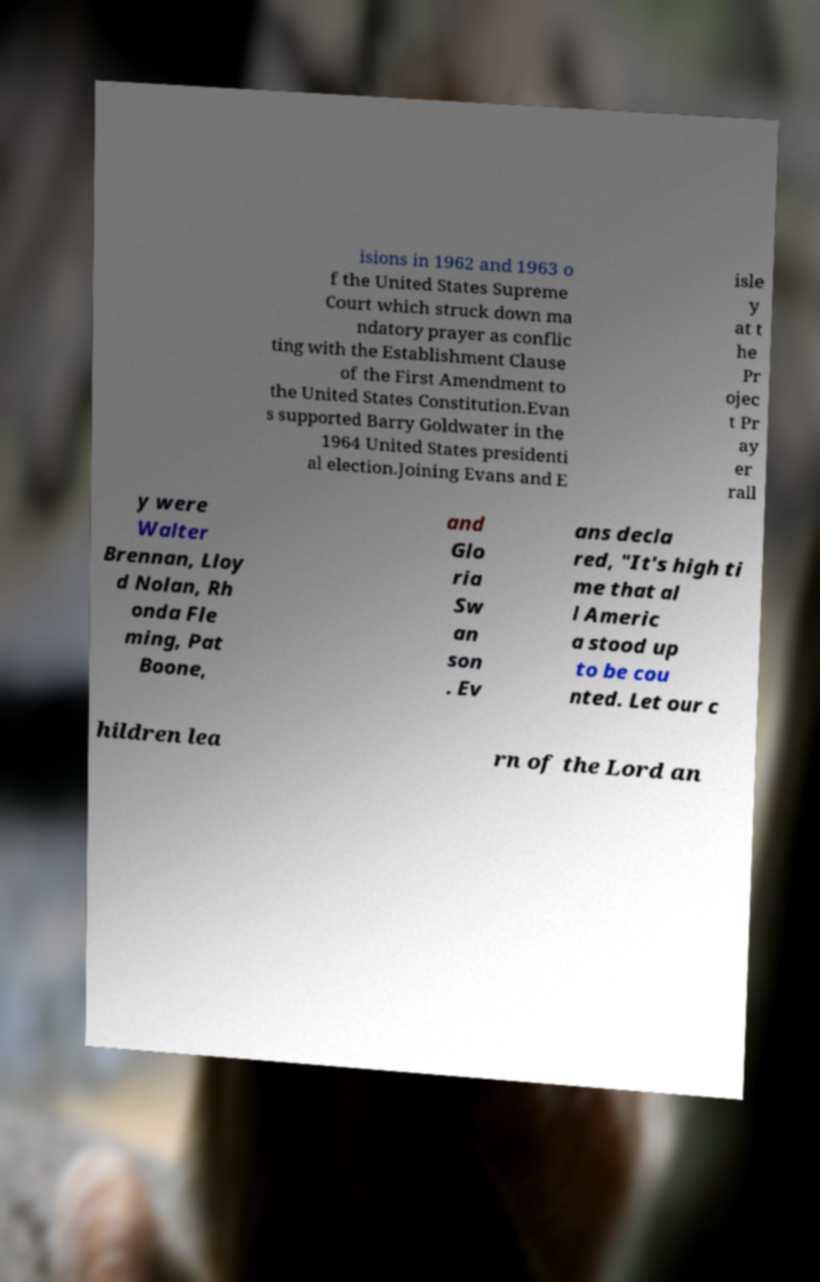Could you assist in decoding the text presented in this image and type it out clearly? isions in 1962 and 1963 o f the United States Supreme Court which struck down ma ndatory prayer as conflic ting with the Establishment Clause of the First Amendment to the United States Constitution.Evan s supported Barry Goldwater in the 1964 United States presidenti al election.Joining Evans and E isle y at t he Pr ojec t Pr ay er rall y were Walter Brennan, Lloy d Nolan, Rh onda Fle ming, Pat Boone, and Glo ria Sw an son . Ev ans decla red, "It's high ti me that al l Americ a stood up to be cou nted. Let our c hildren lea rn of the Lord an 